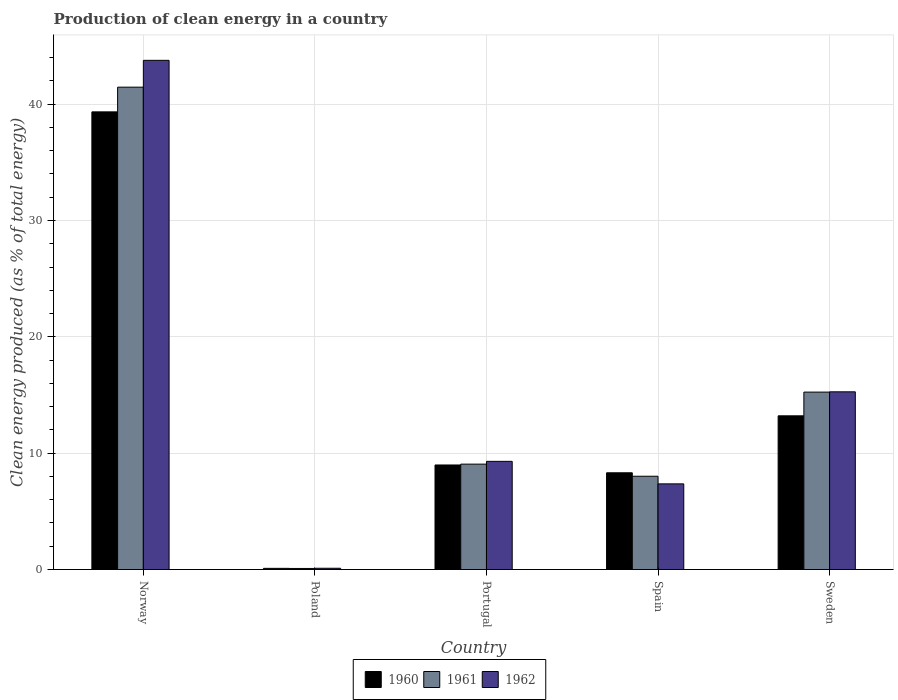Are the number of bars per tick equal to the number of legend labels?
Ensure brevity in your answer.  Yes. How many bars are there on the 5th tick from the left?
Provide a succinct answer. 3. What is the percentage of clean energy produced in 1962 in Poland?
Make the answer very short. 0.11. Across all countries, what is the maximum percentage of clean energy produced in 1961?
Ensure brevity in your answer.  41.46. Across all countries, what is the minimum percentage of clean energy produced in 1960?
Give a very brief answer. 0.1. In which country was the percentage of clean energy produced in 1962 minimum?
Provide a succinct answer. Poland. What is the total percentage of clean energy produced in 1960 in the graph?
Keep it short and to the point. 69.95. What is the difference between the percentage of clean energy produced in 1960 in Norway and that in Poland?
Give a very brief answer. 39.24. What is the difference between the percentage of clean energy produced in 1962 in Spain and the percentage of clean energy produced in 1960 in Norway?
Keep it short and to the point. -31.97. What is the average percentage of clean energy produced in 1960 per country?
Offer a terse response. 13.99. What is the difference between the percentage of clean energy produced of/in 1961 and percentage of clean energy produced of/in 1960 in Portugal?
Offer a terse response. 0.07. What is the ratio of the percentage of clean energy produced in 1962 in Norway to that in Poland?
Provide a succinct answer. 404.39. Is the difference between the percentage of clean energy produced in 1961 in Spain and Sweden greater than the difference between the percentage of clean energy produced in 1960 in Spain and Sweden?
Offer a terse response. No. What is the difference between the highest and the second highest percentage of clean energy produced in 1962?
Give a very brief answer. -34.47. What is the difference between the highest and the lowest percentage of clean energy produced in 1960?
Provide a succinct answer. 39.24. In how many countries, is the percentage of clean energy produced in 1960 greater than the average percentage of clean energy produced in 1960 taken over all countries?
Your answer should be very brief. 1. Is the sum of the percentage of clean energy produced in 1962 in Poland and Spain greater than the maximum percentage of clean energy produced in 1960 across all countries?
Give a very brief answer. No. What does the 3rd bar from the left in Sweden represents?
Make the answer very short. 1962. Is it the case that in every country, the sum of the percentage of clean energy produced in 1961 and percentage of clean energy produced in 1960 is greater than the percentage of clean energy produced in 1962?
Provide a succinct answer. Yes. How many bars are there?
Provide a succinct answer. 15. What is the difference between two consecutive major ticks on the Y-axis?
Make the answer very short. 10. Are the values on the major ticks of Y-axis written in scientific E-notation?
Your answer should be compact. No. Does the graph contain any zero values?
Your response must be concise. No. Where does the legend appear in the graph?
Ensure brevity in your answer.  Bottom center. How are the legend labels stacked?
Your answer should be very brief. Horizontal. What is the title of the graph?
Provide a short and direct response. Production of clean energy in a country. Does "1990" appear as one of the legend labels in the graph?
Give a very brief answer. No. What is the label or title of the X-axis?
Give a very brief answer. Country. What is the label or title of the Y-axis?
Ensure brevity in your answer.  Clean energy produced (as % of total energy). What is the Clean energy produced (as % of total energy) in 1960 in Norway?
Provide a succinct answer. 39.34. What is the Clean energy produced (as % of total energy) in 1961 in Norway?
Your answer should be very brief. 41.46. What is the Clean energy produced (as % of total energy) of 1962 in Norway?
Make the answer very short. 43.77. What is the Clean energy produced (as % of total energy) of 1960 in Poland?
Offer a very short reply. 0.1. What is the Clean energy produced (as % of total energy) of 1961 in Poland?
Your answer should be very brief. 0.09. What is the Clean energy produced (as % of total energy) of 1962 in Poland?
Your answer should be compact. 0.11. What is the Clean energy produced (as % of total energy) of 1960 in Portugal?
Your answer should be compact. 8.99. What is the Clean energy produced (as % of total energy) in 1961 in Portugal?
Give a very brief answer. 9.06. What is the Clean energy produced (as % of total energy) of 1962 in Portugal?
Provide a succinct answer. 9.3. What is the Clean energy produced (as % of total energy) of 1960 in Spain?
Offer a terse response. 8.31. What is the Clean energy produced (as % of total energy) in 1961 in Spain?
Give a very brief answer. 8.02. What is the Clean energy produced (as % of total energy) in 1962 in Spain?
Offer a terse response. 7.36. What is the Clean energy produced (as % of total energy) of 1960 in Sweden?
Your response must be concise. 13.21. What is the Clean energy produced (as % of total energy) in 1961 in Sweden?
Your response must be concise. 15.25. What is the Clean energy produced (as % of total energy) in 1962 in Sweden?
Keep it short and to the point. 15.27. Across all countries, what is the maximum Clean energy produced (as % of total energy) in 1960?
Keep it short and to the point. 39.34. Across all countries, what is the maximum Clean energy produced (as % of total energy) in 1961?
Provide a succinct answer. 41.46. Across all countries, what is the maximum Clean energy produced (as % of total energy) of 1962?
Provide a short and direct response. 43.77. Across all countries, what is the minimum Clean energy produced (as % of total energy) of 1960?
Your answer should be very brief. 0.1. Across all countries, what is the minimum Clean energy produced (as % of total energy) of 1961?
Ensure brevity in your answer.  0.09. Across all countries, what is the minimum Clean energy produced (as % of total energy) of 1962?
Ensure brevity in your answer.  0.11. What is the total Clean energy produced (as % of total energy) in 1960 in the graph?
Make the answer very short. 69.95. What is the total Clean energy produced (as % of total energy) of 1961 in the graph?
Offer a terse response. 73.88. What is the total Clean energy produced (as % of total energy) of 1962 in the graph?
Ensure brevity in your answer.  75.81. What is the difference between the Clean energy produced (as % of total energy) in 1960 in Norway and that in Poland?
Make the answer very short. 39.24. What is the difference between the Clean energy produced (as % of total energy) in 1961 in Norway and that in Poland?
Ensure brevity in your answer.  41.37. What is the difference between the Clean energy produced (as % of total energy) of 1962 in Norway and that in Poland?
Ensure brevity in your answer.  43.66. What is the difference between the Clean energy produced (as % of total energy) of 1960 in Norway and that in Portugal?
Your answer should be compact. 30.35. What is the difference between the Clean energy produced (as % of total energy) in 1961 in Norway and that in Portugal?
Your response must be concise. 32.4. What is the difference between the Clean energy produced (as % of total energy) in 1962 in Norway and that in Portugal?
Give a very brief answer. 34.47. What is the difference between the Clean energy produced (as % of total energy) of 1960 in Norway and that in Spain?
Provide a succinct answer. 31.02. What is the difference between the Clean energy produced (as % of total energy) of 1961 in Norway and that in Spain?
Offer a very short reply. 33.44. What is the difference between the Clean energy produced (as % of total energy) in 1962 in Norway and that in Spain?
Provide a short and direct response. 36.4. What is the difference between the Clean energy produced (as % of total energy) in 1960 in Norway and that in Sweden?
Ensure brevity in your answer.  26.12. What is the difference between the Clean energy produced (as % of total energy) in 1961 in Norway and that in Sweden?
Your answer should be compact. 26.21. What is the difference between the Clean energy produced (as % of total energy) of 1962 in Norway and that in Sweden?
Make the answer very short. 28.49. What is the difference between the Clean energy produced (as % of total energy) of 1960 in Poland and that in Portugal?
Offer a terse response. -8.88. What is the difference between the Clean energy produced (as % of total energy) in 1961 in Poland and that in Portugal?
Your answer should be very brief. -8.97. What is the difference between the Clean energy produced (as % of total energy) of 1962 in Poland and that in Portugal?
Your answer should be compact. -9.19. What is the difference between the Clean energy produced (as % of total energy) of 1960 in Poland and that in Spain?
Give a very brief answer. -8.21. What is the difference between the Clean energy produced (as % of total energy) of 1961 in Poland and that in Spain?
Make the answer very short. -7.93. What is the difference between the Clean energy produced (as % of total energy) of 1962 in Poland and that in Spain?
Offer a terse response. -7.25. What is the difference between the Clean energy produced (as % of total energy) of 1960 in Poland and that in Sweden?
Give a very brief answer. -13.11. What is the difference between the Clean energy produced (as % of total energy) in 1961 in Poland and that in Sweden?
Make the answer very short. -15.16. What is the difference between the Clean energy produced (as % of total energy) of 1962 in Poland and that in Sweden?
Ensure brevity in your answer.  -15.17. What is the difference between the Clean energy produced (as % of total energy) of 1960 in Portugal and that in Spain?
Offer a very short reply. 0.67. What is the difference between the Clean energy produced (as % of total energy) of 1961 in Portugal and that in Spain?
Offer a very short reply. 1.04. What is the difference between the Clean energy produced (as % of total energy) in 1962 in Portugal and that in Spain?
Offer a very short reply. 1.94. What is the difference between the Clean energy produced (as % of total energy) of 1960 in Portugal and that in Sweden?
Provide a short and direct response. -4.23. What is the difference between the Clean energy produced (as % of total energy) in 1961 in Portugal and that in Sweden?
Make the answer very short. -6.19. What is the difference between the Clean energy produced (as % of total energy) of 1962 in Portugal and that in Sweden?
Provide a succinct answer. -5.98. What is the difference between the Clean energy produced (as % of total energy) of 1960 in Spain and that in Sweden?
Your response must be concise. -4.9. What is the difference between the Clean energy produced (as % of total energy) in 1961 in Spain and that in Sweden?
Provide a succinct answer. -7.23. What is the difference between the Clean energy produced (as % of total energy) of 1962 in Spain and that in Sweden?
Offer a terse response. -7.91. What is the difference between the Clean energy produced (as % of total energy) in 1960 in Norway and the Clean energy produced (as % of total energy) in 1961 in Poland?
Your answer should be compact. 39.24. What is the difference between the Clean energy produced (as % of total energy) in 1960 in Norway and the Clean energy produced (as % of total energy) in 1962 in Poland?
Your answer should be compact. 39.23. What is the difference between the Clean energy produced (as % of total energy) in 1961 in Norway and the Clean energy produced (as % of total energy) in 1962 in Poland?
Your response must be concise. 41.35. What is the difference between the Clean energy produced (as % of total energy) of 1960 in Norway and the Clean energy produced (as % of total energy) of 1961 in Portugal?
Provide a succinct answer. 30.28. What is the difference between the Clean energy produced (as % of total energy) in 1960 in Norway and the Clean energy produced (as % of total energy) in 1962 in Portugal?
Give a very brief answer. 30.04. What is the difference between the Clean energy produced (as % of total energy) of 1961 in Norway and the Clean energy produced (as % of total energy) of 1962 in Portugal?
Give a very brief answer. 32.16. What is the difference between the Clean energy produced (as % of total energy) of 1960 in Norway and the Clean energy produced (as % of total energy) of 1961 in Spain?
Your response must be concise. 31.32. What is the difference between the Clean energy produced (as % of total energy) in 1960 in Norway and the Clean energy produced (as % of total energy) in 1962 in Spain?
Your response must be concise. 31.97. What is the difference between the Clean energy produced (as % of total energy) of 1961 in Norway and the Clean energy produced (as % of total energy) of 1962 in Spain?
Ensure brevity in your answer.  34.1. What is the difference between the Clean energy produced (as % of total energy) of 1960 in Norway and the Clean energy produced (as % of total energy) of 1961 in Sweden?
Give a very brief answer. 24.09. What is the difference between the Clean energy produced (as % of total energy) of 1960 in Norway and the Clean energy produced (as % of total energy) of 1962 in Sweden?
Provide a succinct answer. 24.06. What is the difference between the Clean energy produced (as % of total energy) in 1961 in Norway and the Clean energy produced (as % of total energy) in 1962 in Sweden?
Offer a terse response. 26.19. What is the difference between the Clean energy produced (as % of total energy) of 1960 in Poland and the Clean energy produced (as % of total energy) of 1961 in Portugal?
Offer a very short reply. -8.96. What is the difference between the Clean energy produced (as % of total energy) in 1960 in Poland and the Clean energy produced (as % of total energy) in 1962 in Portugal?
Your response must be concise. -9.2. What is the difference between the Clean energy produced (as % of total energy) in 1961 in Poland and the Clean energy produced (as % of total energy) in 1962 in Portugal?
Your answer should be very brief. -9.21. What is the difference between the Clean energy produced (as % of total energy) in 1960 in Poland and the Clean energy produced (as % of total energy) in 1961 in Spain?
Your response must be concise. -7.92. What is the difference between the Clean energy produced (as % of total energy) of 1960 in Poland and the Clean energy produced (as % of total energy) of 1962 in Spain?
Ensure brevity in your answer.  -7.26. What is the difference between the Clean energy produced (as % of total energy) in 1961 in Poland and the Clean energy produced (as % of total energy) in 1962 in Spain?
Keep it short and to the point. -7.27. What is the difference between the Clean energy produced (as % of total energy) in 1960 in Poland and the Clean energy produced (as % of total energy) in 1961 in Sweden?
Make the answer very short. -15.15. What is the difference between the Clean energy produced (as % of total energy) of 1960 in Poland and the Clean energy produced (as % of total energy) of 1962 in Sweden?
Provide a succinct answer. -15.17. What is the difference between the Clean energy produced (as % of total energy) in 1961 in Poland and the Clean energy produced (as % of total energy) in 1962 in Sweden?
Your answer should be compact. -15.18. What is the difference between the Clean energy produced (as % of total energy) of 1960 in Portugal and the Clean energy produced (as % of total energy) of 1961 in Spain?
Keep it short and to the point. 0.97. What is the difference between the Clean energy produced (as % of total energy) of 1960 in Portugal and the Clean energy produced (as % of total energy) of 1962 in Spain?
Keep it short and to the point. 1.62. What is the difference between the Clean energy produced (as % of total energy) of 1961 in Portugal and the Clean energy produced (as % of total energy) of 1962 in Spain?
Your response must be concise. 1.7. What is the difference between the Clean energy produced (as % of total energy) of 1960 in Portugal and the Clean energy produced (as % of total energy) of 1961 in Sweden?
Make the answer very short. -6.26. What is the difference between the Clean energy produced (as % of total energy) in 1960 in Portugal and the Clean energy produced (as % of total energy) in 1962 in Sweden?
Your response must be concise. -6.29. What is the difference between the Clean energy produced (as % of total energy) of 1961 in Portugal and the Clean energy produced (as % of total energy) of 1962 in Sweden?
Keep it short and to the point. -6.21. What is the difference between the Clean energy produced (as % of total energy) of 1960 in Spain and the Clean energy produced (as % of total energy) of 1961 in Sweden?
Give a very brief answer. -6.94. What is the difference between the Clean energy produced (as % of total energy) in 1960 in Spain and the Clean energy produced (as % of total energy) in 1962 in Sweden?
Your response must be concise. -6.96. What is the difference between the Clean energy produced (as % of total energy) of 1961 in Spain and the Clean energy produced (as % of total energy) of 1962 in Sweden?
Offer a very short reply. -7.26. What is the average Clean energy produced (as % of total energy) of 1960 per country?
Provide a succinct answer. 13.99. What is the average Clean energy produced (as % of total energy) in 1961 per country?
Keep it short and to the point. 14.78. What is the average Clean energy produced (as % of total energy) in 1962 per country?
Your response must be concise. 15.16. What is the difference between the Clean energy produced (as % of total energy) of 1960 and Clean energy produced (as % of total energy) of 1961 in Norway?
Keep it short and to the point. -2.12. What is the difference between the Clean energy produced (as % of total energy) in 1960 and Clean energy produced (as % of total energy) in 1962 in Norway?
Provide a succinct answer. -4.43. What is the difference between the Clean energy produced (as % of total energy) in 1961 and Clean energy produced (as % of total energy) in 1962 in Norway?
Ensure brevity in your answer.  -2.31. What is the difference between the Clean energy produced (as % of total energy) in 1960 and Clean energy produced (as % of total energy) in 1961 in Poland?
Ensure brevity in your answer.  0.01. What is the difference between the Clean energy produced (as % of total energy) in 1960 and Clean energy produced (as % of total energy) in 1962 in Poland?
Offer a very short reply. -0.01. What is the difference between the Clean energy produced (as % of total energy) of 1961 and Clean energy produced (as % of total energy) of 1962 in Poland?
Your response must be concise. -0.02. What is the difference between the Clean energy produced (as % of total energy) in 1960 and Clean energy produced (as % of total energy) in 1961 in Portugal?
Ensure brevity in your answer.  -0.07. What is the difference between the Clean energy produced (as % of total energy) of 1960 and Clean energy produced (as % of total energy) of 1962 in Portugal?
Your answer should be compact. -0.31. What is the difference between the Clean energy produced (as % of total energy) of 1961 and Clean energy produced (as % of total energy) of 1962 in Portugal?
Offer a very short reply. -0.24. What is the difference between the Clean energy produced (as % of total energy) of 1960 and Clean energy produced (as % of total energy) of 1961 in Spain?
Provide a succinct answer. 0.3. What is the difference between the Clean energy produced (as % of total energy) of 1960 and Clean energy produced (as % of total energy) of 1962 in Spain?
Provide a short and direct response. 0.95. What is the difference between the Clean energy produced (as % of total energy) in 1961 and Clean energy produced (as % of total energy) in 1962 in Spain?
Offer a terse response. 0.66. What is the difference between the Clean energy produced (as % of total energy) in 1960 and Clean energy produced (as % of total energy) in 1961 in Sweden?
Ensure brevity in your answer.  -2.04. What is the difference between the Clean energy produced (as % of total energy) in 1960 and Clean energy produced (as % of total energy) in 1962 in Sweden?
Offer a very short reply. -2.06. What is the difference between the Clean energy produced (as % of total energy) of 1961 and Clean energy produced (as % of total energy) of 1962 in Sweden?
Your answer should be compact. -0.02. What is the ratio of the Clean energy produced (as % of total energy) in 1960 in Norway to that in Poland?
Offer a very short reply. 392.08. What is the ratio of the Clean energy produced (as % of total energy) of 1961 in Norway to that in Poland?
Offer a terse response. 452.99. What is the ratio of the Clean energy produced (as % of total energy) of 1962 in Norway to that in Poland?
Your response must be concise. 404.39. What is the ratio of the Clean energy produced (as % of total energy) of 1960 in Norway to that in Portugal?
Make the answer very short. 4.38. What is the ratio of the Clean energy produced (as % of total energy) in 1961 in Norway to that in Portugal?
Your response must be concise. 4.58. What is the ratio of the Clean energy produced (as % of total energy) in 1962 in Norway to that in Portugal?
Your answer should be compact. 4.71. What is the ratio of the Clean energy produced (as % of total energy) in 1960 in Norway to that in Spain?
Offer a terse response. 4.73. What is the ratio of the Clean energy produced (as % of total energy) of 1961 in Norway to that in Spain?
Provide a short and direct response. 5.17. What is the ratio of the Clean energy produced (as % of total energy) of 1962 in Norway to that in Spain?
Provide a short and direct response. 5.94. What is the ratio of the Clean energy produced (as % of total energy) in 1960 in Norway to that in Sweden?
Ensure brevity in your answer.  2.98. What is the ratio of the Clean energy produced (as % of total energy) in 1961 in Norway to that in Sweden?
Keep it short and to the point. 2.72. What is the ratio of the Clean energy produced (as % of total energy) of 1962 in Norway to that in Sweden?
Keep it short and to the point. 2.87. What is the ratio of the Clean energy produced (as % of total energy) in 1960 in Poland to that in Portugal?
Your answer should be very brief. 0.01. What is the ratio of the Clean energy produced (as % of total energy) of 1961 in Poland to that in Portugal?
Give a very brief answer. 0.01. What is the ratio of the Clean energy produced (as % of total energy) in 1962 in Poland to that in Portugal?
Your response must be concise. 0.01. What is the ratio of the Clean energy produced (as % of total energy) in 1960 in Poland to that in Spain?
Ensure brevity in your answer.  0.01. What is the ratio of the Clean energy produced (as % of total energy) of 1961 in Poland to that in Spain?
Offer a terse response. 0.01. What is the ratio of the Clean energy produced (as % of total energy) of 1962 in Poland to that in Spain?
Keep it short and to the point. 0.01. What is the ratio of the Clean energy produced (as % of total energy) in 1960 in Poland to that in Sweden?
Ensure brevity in your answer.  0.01. What is the ratio of the Clean energy produced (as % of total energy) of 1961 in Poland to that in Sweden?
Your response must be concise. 0.01. What is the ratio of the Clean energy produced (as % of total energy) of 1962 in Poland to that in Sweden?
Offer a terse response. 0.01. What is the ratio of the Clean energy produced (as % of total energy) of 1960 in Portugal to that in Spain?
Provide a short and direct response. 1.08. What is the ratio of the Clean energy produced (as % of total energy) in 1961 in Portugal to that in Spain?
Offer a terse response. 1.13. What is the ratio of the Clean energy produced (as % of total energy) in 1962 in Portugal to that in Spain?
Your answer should be compact. 1.26. What is the ratio of the Clean energy produced (as % of total energy) of 1960 in Portugal to that in Sweden?
Your response must be concise. 0.68. What is the ratio of the Clean energy produced (as % of total energy) of 1961 in Portugal to that in Sweden?
Give a very brief answer. 0.59. What is the ratio of the Clean energy produced (as % of total energy) in 1962 in Portugal to that in Sweden?
Your answer should be very brief. 0.61. What is the ratio of the Clean energy produced (as % of total energy) of 1960 in Spain to that in Sweden?
Offer a very short reply. 0.63. What is the ratio of the Clean energy produced (as % of total energy) in 1961 in Spain to that in Sweden?
Your response must be concise. 0.53. What is the ratio of the Clean energy produced (as % of total energy) in 1962 in Spain to that in Sweden?
Keep it short and to the point. 0.48. What is the difference between the highest and the second highest Clean energy produced (as % of total energy) of 1960?
Your response must be concise. 26.12. What is the difference between the highest and the second highest Clean energy produced (as % of total energy) of 1961?
Make the answer very short. 26.21. What is the difference between the highest and the second highest Clean energy produced (as % of total energy) in 1962?
Your answer should be compact. 28.49. What is the difference between the highest and the lowest Clean energy produced (as % of total energy) in 1960?
Keep it short and to the point. 39.24. What is the difference between the highest and the lowest Clean energy produced (as % of total energy) in 1961?
Make the answer very short. 41.37. What is the difference between the highest and the lowest Clean energy produced (as % of total energy) in 1962?
Offer a terse response. 43.66. 